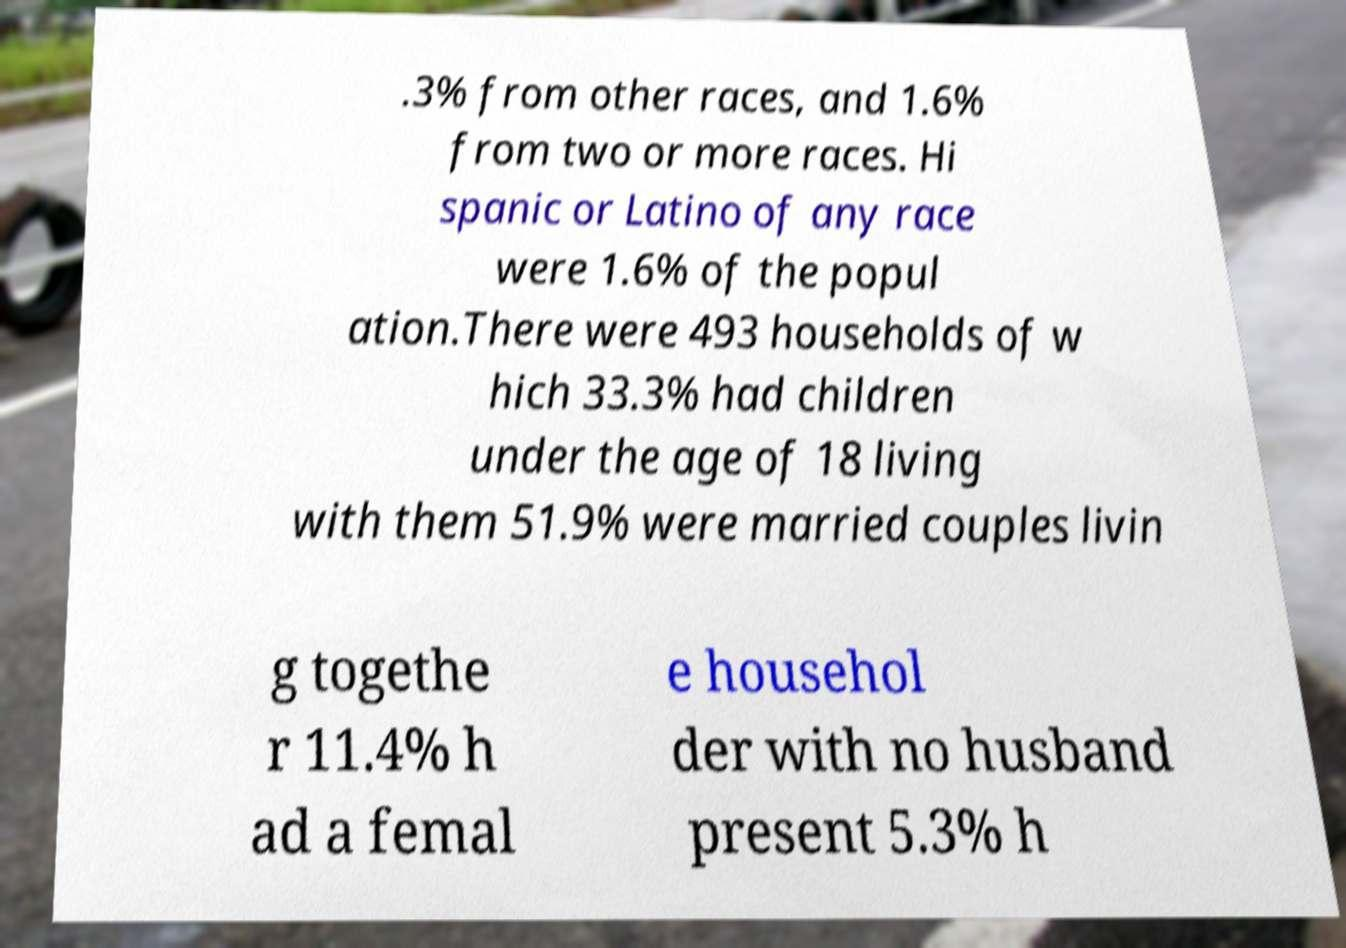Can you read and provide the text displayed in the image?This photo seems to have some interesting text. Can you extract and type it out for me? .3% from other races, and 1.6% from two or more races. Hi spanic or Latino of any race were 1.6% of the popul ation.There were 493 households of w hich 33.3% had children under the age of 18 living with them 51.9% were married couples livin g togethe r 11.4% h ad a femal e househol der with no husband present 5.3% h 